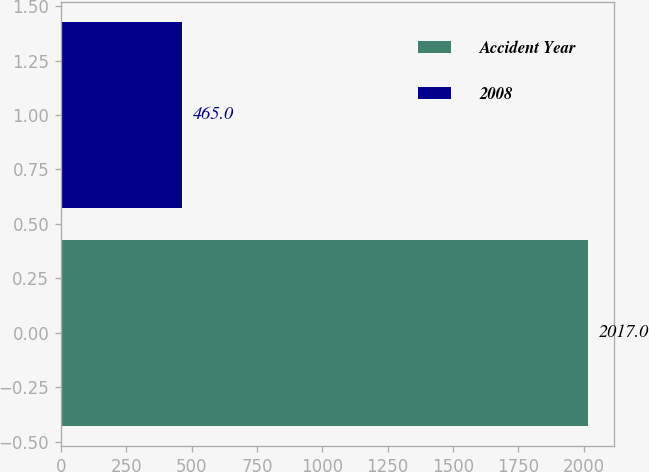Convert chart to OTSL. <chart><loc_0><loc_0><loc_500><loc_500><bar_chart><fcel>Accident Year<fcel>2008<nl><fcel>2017<fcel>465<nl></chart> 